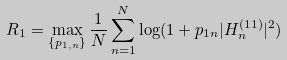<formula> <loc_0><loc_0><loc_500><loc_500>R _ { 1 } = \max _ { \{ p _ { 1 , n } \} } \frac { 1 } { N } \sum _ { n = 1 } ^ { N } \log ( 1 + p _ { 1 n } | H _ { n } ^ { ( 1 1 ) } | ^ { 2 } )</formula> 